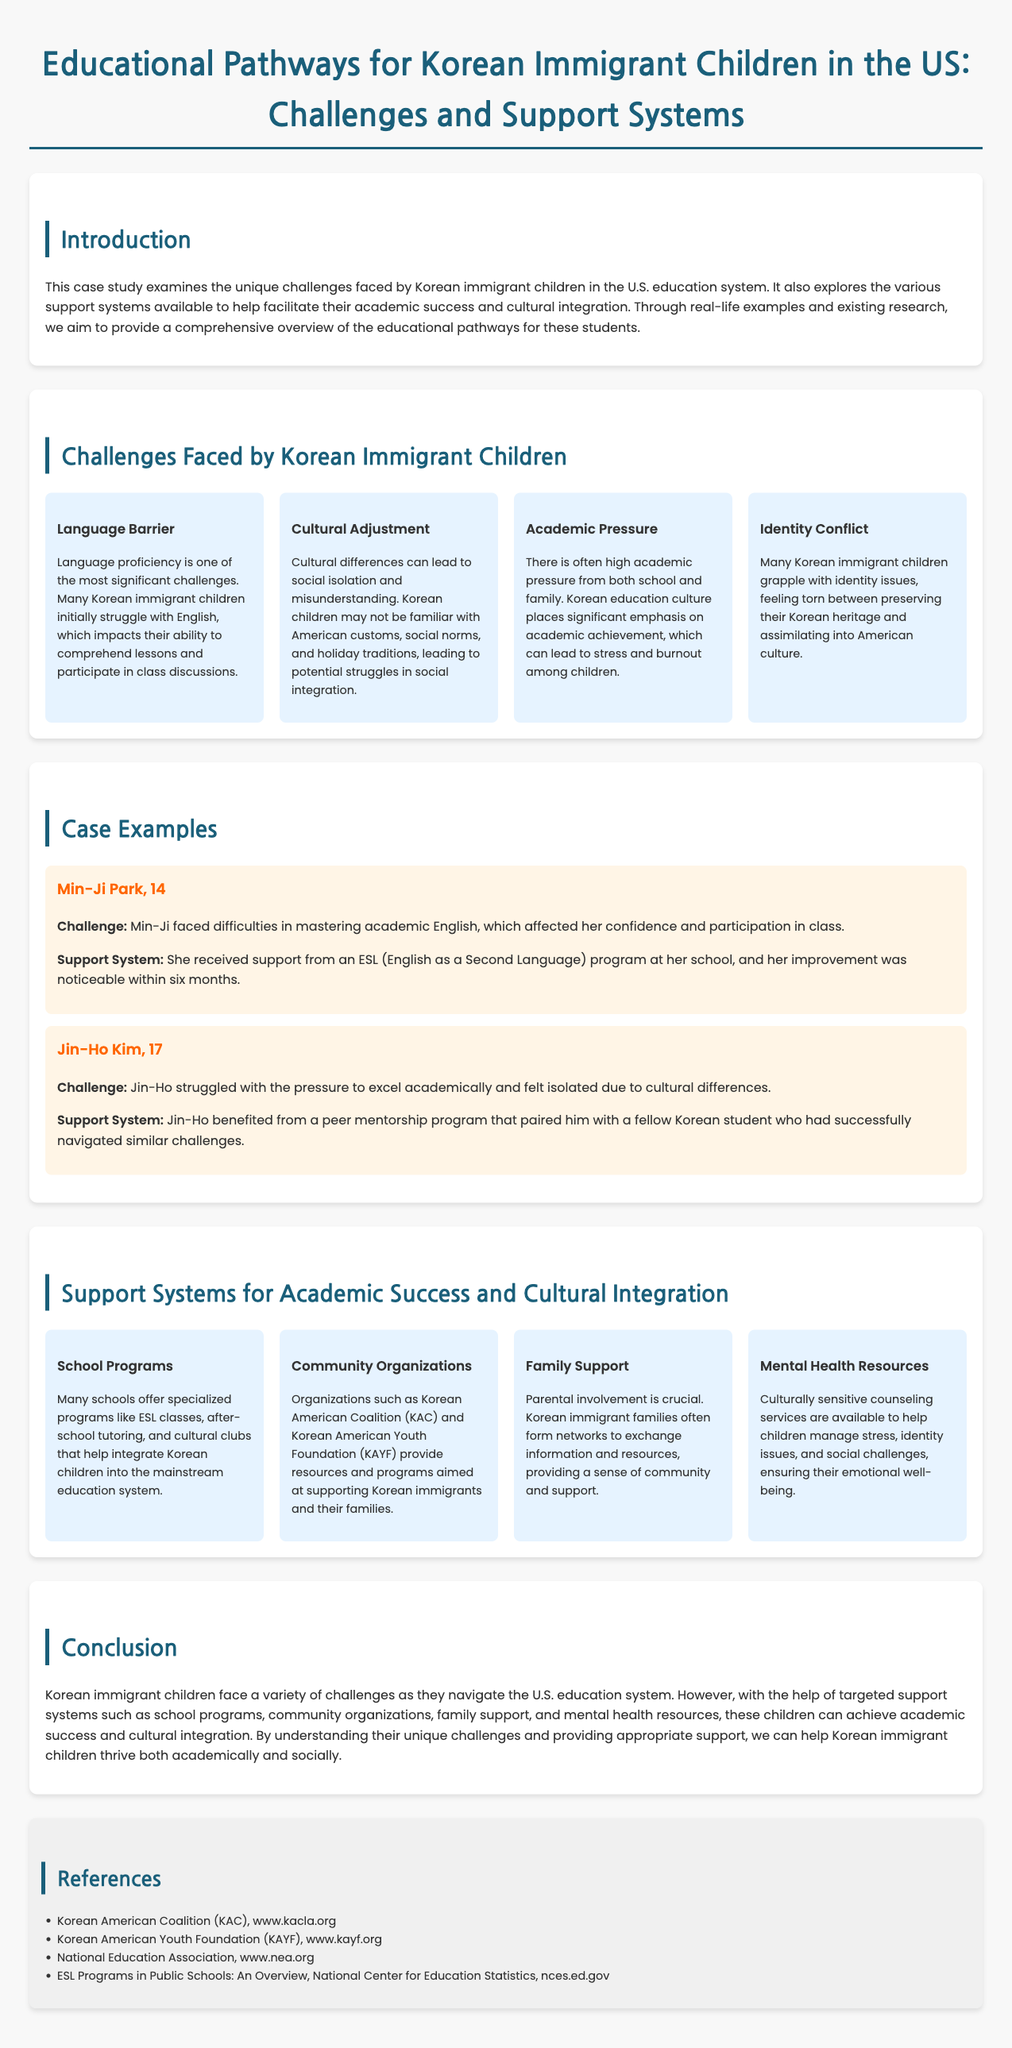what is the main focus of the case study? The main focus is on the challenges faced by Korean immigrant children in the U.S. education system and the support systems available for their academic success and cultural integration.
Answer: challenges and support systems how many challenges are listed in the document? There are four challenges listed that Korean immigrant children face in the U.S. education system.
Answer: four who is the first case example mentioned? The first case example mentioned is Min-Ji Park, who is 14 years old.
Answer: Min-Ji Park what type of support system helped Min-Ji Park? Min-Ji received support from an ESL (English as a Second Language) program at her school.
Answer: ESL program which organization is mentioned as providing resources for Korean immigrants? The Korean American Coalition (KAC) is mentioned as providing resources for Korean immigrants.
Answer: Korean American Coalition (KAC) what is a significant cultural challenge mentioned in the case study? A significant cultural challenge is the cultural adjustment, which can lead to social isolation and misunderstanding.
Answer: cultural adjustment how many years old is Jin-Ho Kim? Jin-Ho Kim is 17 years old.
Answer: 17 which support system focuses on mental health? The document mentions culturally sensitive counseling services as a mental health support system.
Answer: culturally sensitive counseling services 